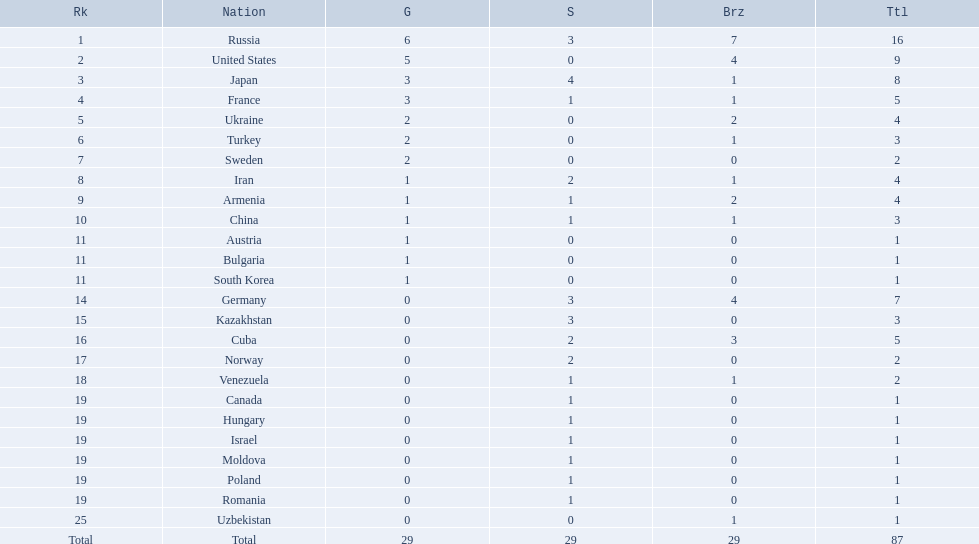Where did iran rank? 8. Would you be able to parse every entry in this table? {'header': ['Rk', 'Nation', 'G', 'S', 'Brz', 'Ttl'], 'rows': [['1', 'Russia', '6', '3', '7', '16'], ['2', 'United States', '5', '0', '4', '9'], ['3', 'Japan', '3', '4', '1', '8'], ['4', 'France', '3', '1', '1', '5'], ['5', 'Ukraine', '2', '0', '2', '4'], ['6', 'Turkey', '2', '0', '1', '3'], ['7', 'Sweden', '2', '0', '0', '2'], ['8', 'Iran', '1', '2', '1', '4'], ['9', 'Armenia', '1', '1', '2', '4'], ['10', 'China', '1', '1', '1', '3'], ['11', 'Austria', '1', '0', '0', '1'], ['11', 'Bulgaria', '1', '0', '0', '1'], ['11', 'South Korea', '1', '0', '0', '1'], ['14', 'Germany', '0', '3', '4', '7'], ['15', 'Kazakhstan', '0', '3', '0', '3'], ['16', 'Cuba', '0', '2', '3', '5'], ['17', 'Norway', '0', '2', '0', '2'], ['18', 'Venezuela', '0', '1', '1', '2'], ['19', 'Canada', '0', '1', '0', '1'], ['19', 'Hungary', '0', '1', '0', '1'], ['19', 'Israel', '0', '1', '0', '1'], ['19', 'Moldova', '0', '1', '0', '1'], ['19', 'Poland', '0', '1', '0', '1'], ['19', 'Romania', '0', '1', '0', '1'], ['25', 'Uzbekistan', '0', '0', '1', '1'], ['Total', 'Total', '29', '29', '29', '87']]} Where did germany rank? 14. Which of those did make it into the top 10 rank? Germany. Which nations only won less then 5 medals? Ukraine, Turkey, Sweden, Iran, Armenia, China, Austria, Bulgaria, South Korea, Germany, Kazakhstan, Norway, Venezuela, Canada, Hungary, Israel, Moldova, Poland, Romania, Uzbekistan. Which of these were not asian nations? Ukraine, Turkey, Sweden, Iran, Armenia, Austria, Bulgaria, Germany, Kazakhstan, Norway, Venezuela, Canada, Hungary, Israel, Moldova, Poland, Romania, Uzbekistan. Which of those did not win any silver medals? Ukraine, Turkey, Sweden, Austria, Bulgaria, Uzbekistan. Which ones of these had only one medal total? Austria, Bulgaria, Uzbekistan. Which of those would be listed first alphabetically? Austria. 